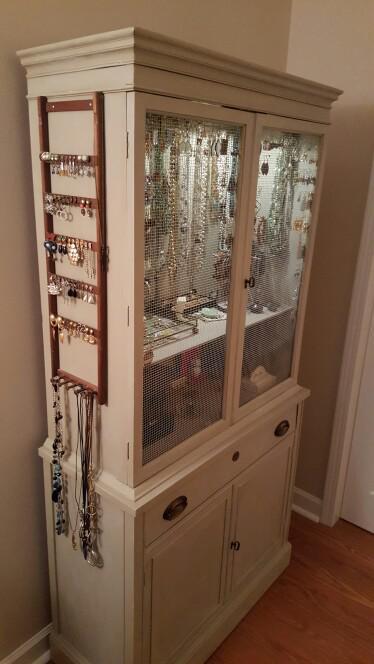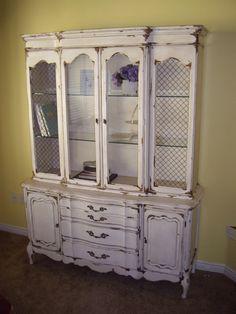The first image is the image on the left, the second image is the image on the right. For the images shown, is this caption "A wooden cabinet in one image stands of long spindle legs, and has solid panels on each side of a wide glass door, and a full-width drawer with two pulls." true? Answer yes or no. No. The first image is the image on the left, the second image is the image on the right. Considering the images on both sides, is "The cabinet in the right image is light green." valid? Answer yes or no. No. 